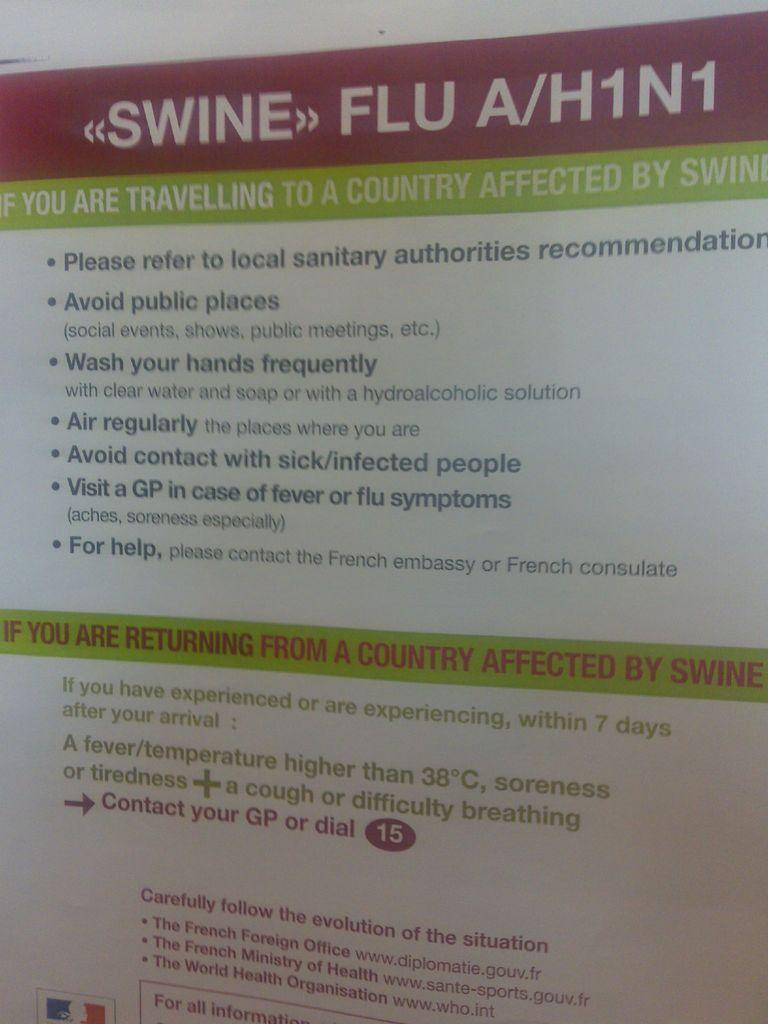<image>
Give a short and clear explanation of the subsequent image. A swine flu A/H1N1 information sheet about traveling. and health information. 